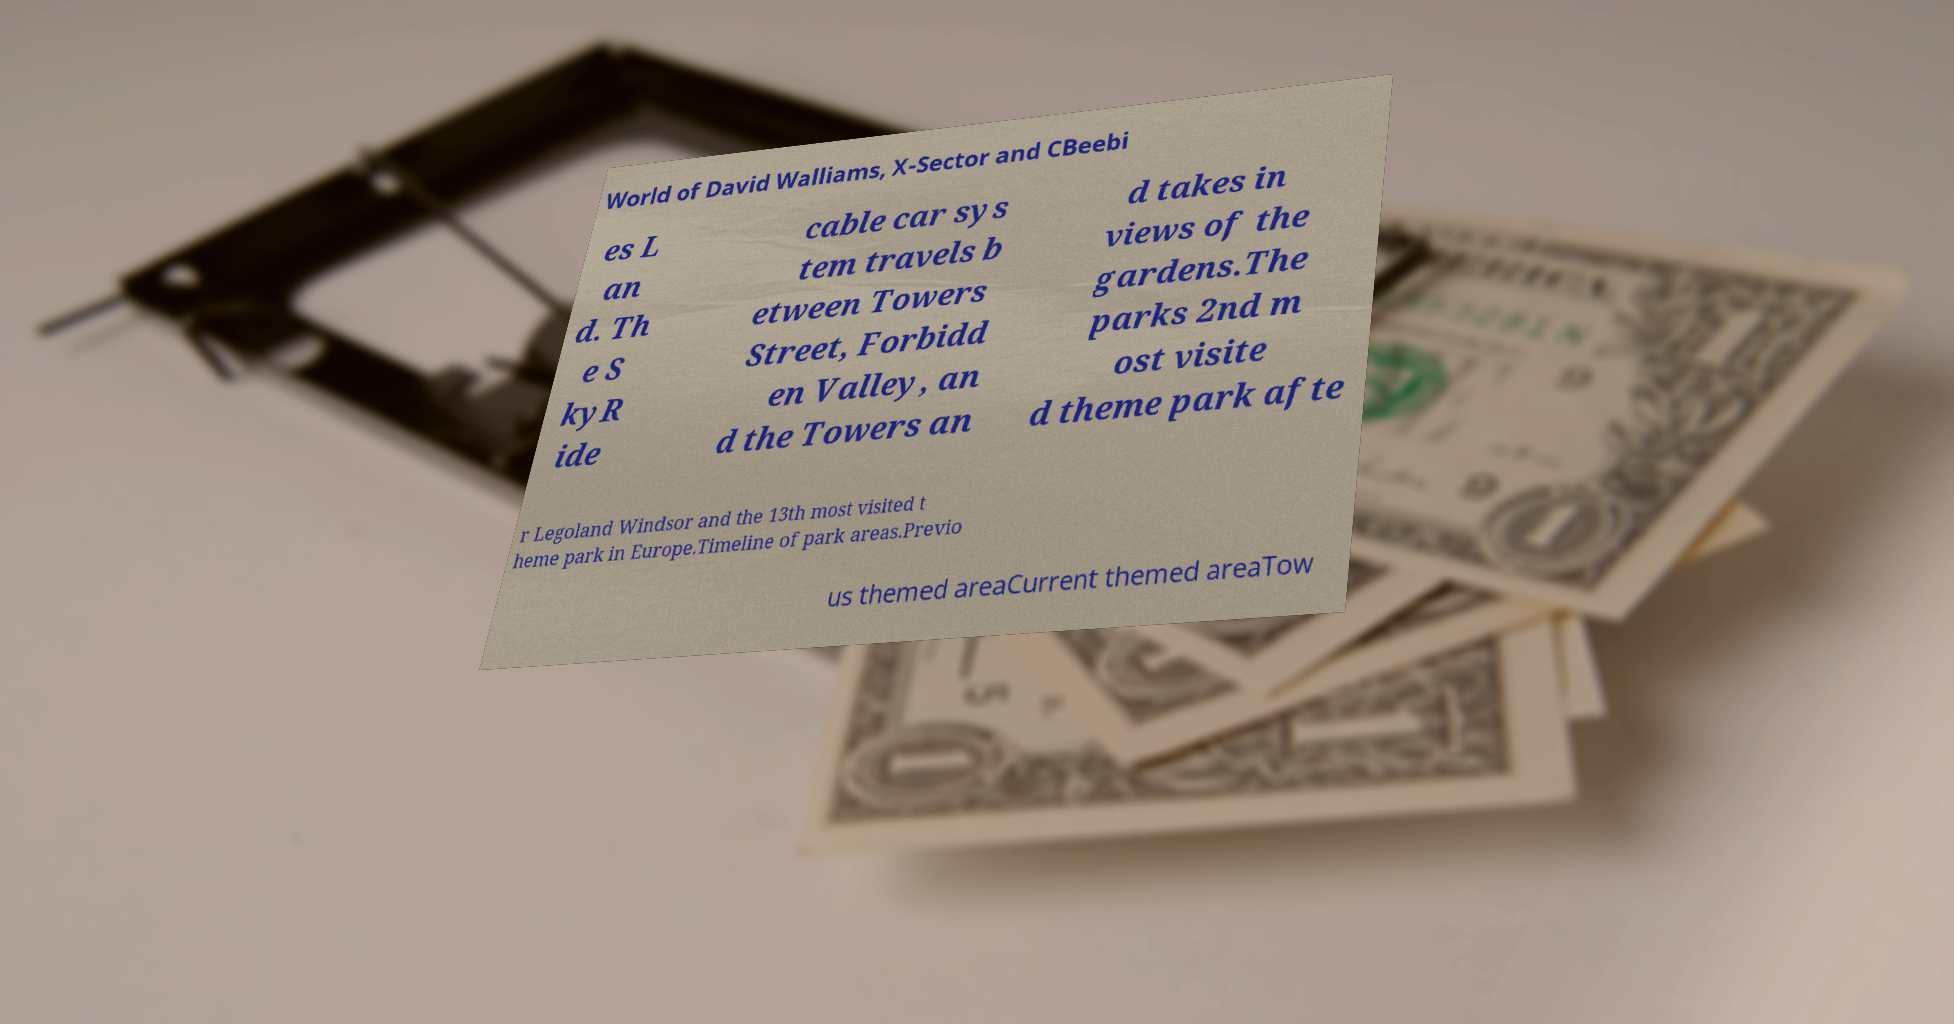Could you extract and type out the text from this image? World of David Walliams, X-Sector and CBeebi es L an d. Th e S kyR ide cable car sys tem travels b etween Towers Street, Forbidd en Valley, an d the Towers an d takes in views of the gardens.The parks 2nd m ost visite d theme park afte r Legoland Windsor and the 13th most visited t heme park in Europe.Timeline of park areas.Previo us themed areaCurrent themed areaTow 